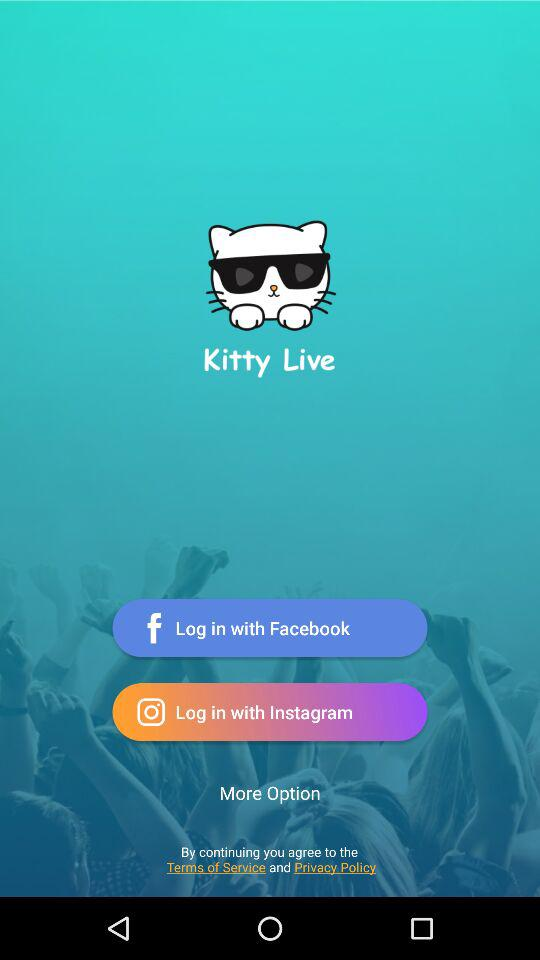What is the name of the application? The name of the application is "Kitty Live". 